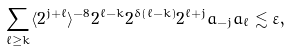<formula> <loc_0><loc_0><loc_500><loc_500>\sum _ { \ell \geq k } \langle 2 ^ { j + \ell } \rangle ^ { - 8 } 2 ^ { \ell - k } 2 ^ { \delta ( \ell - k ) } 2 ^ { \ell + j } a _ { - j } a _ { \ell } \lesssim \varepsilon ,</formula> 